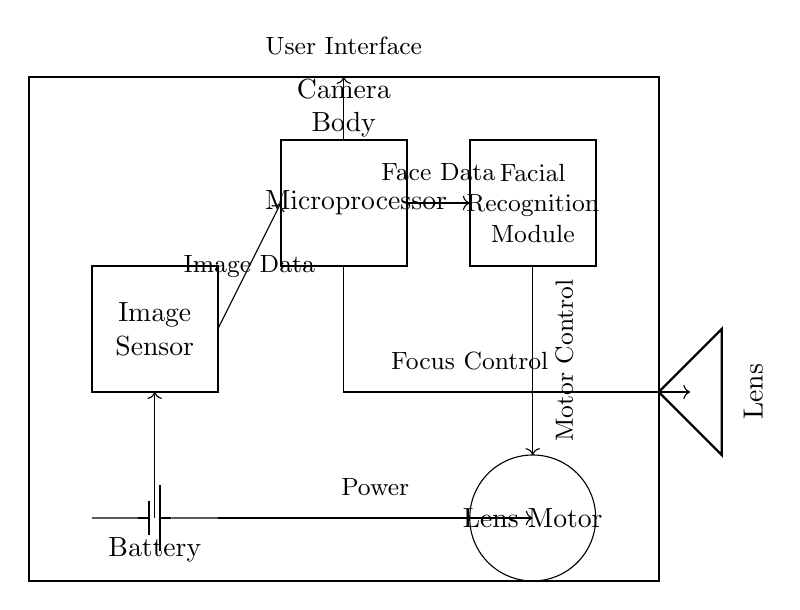What is the primary function of the lens motor? The lens motor is responsible for adjusting the focus of the lens, as indicated by the connection labeled “Motor Control.”
Answer: Adjusting focus What component processes the image data? The image sensor processes the image data, which is directly connected to the microprocessor.
Answer: Image sensor What is the purpose of the facial recognition module? The facial recognition module is designed to identify and track royal family members based on facial features, as it receives data from the microprocessor labeled “Face Data.”
Answer: Identification and tracking Which component provides power to the circuit? The battery provides power, as shown by the connection that supplies electricity to other components.
Answer: Battery How does the image data travel through the circuit? The image data travels from the image sensor to the microprocessor, and is denoted by the arrow between these two components.
Answer: Through the microprocessor What type of device is this circuit primarily designed for? This circuit is primarily designed for a camera, indicated by the labeling of components like camera body, image sensor, and lens.
Answer: Camera How many main components are directly involved in processing and focusing? There are three main components involved: the image sensor, microprocessor, and lens motor, all of which play crucial roles in image processing and focus control.
Answer: Three 